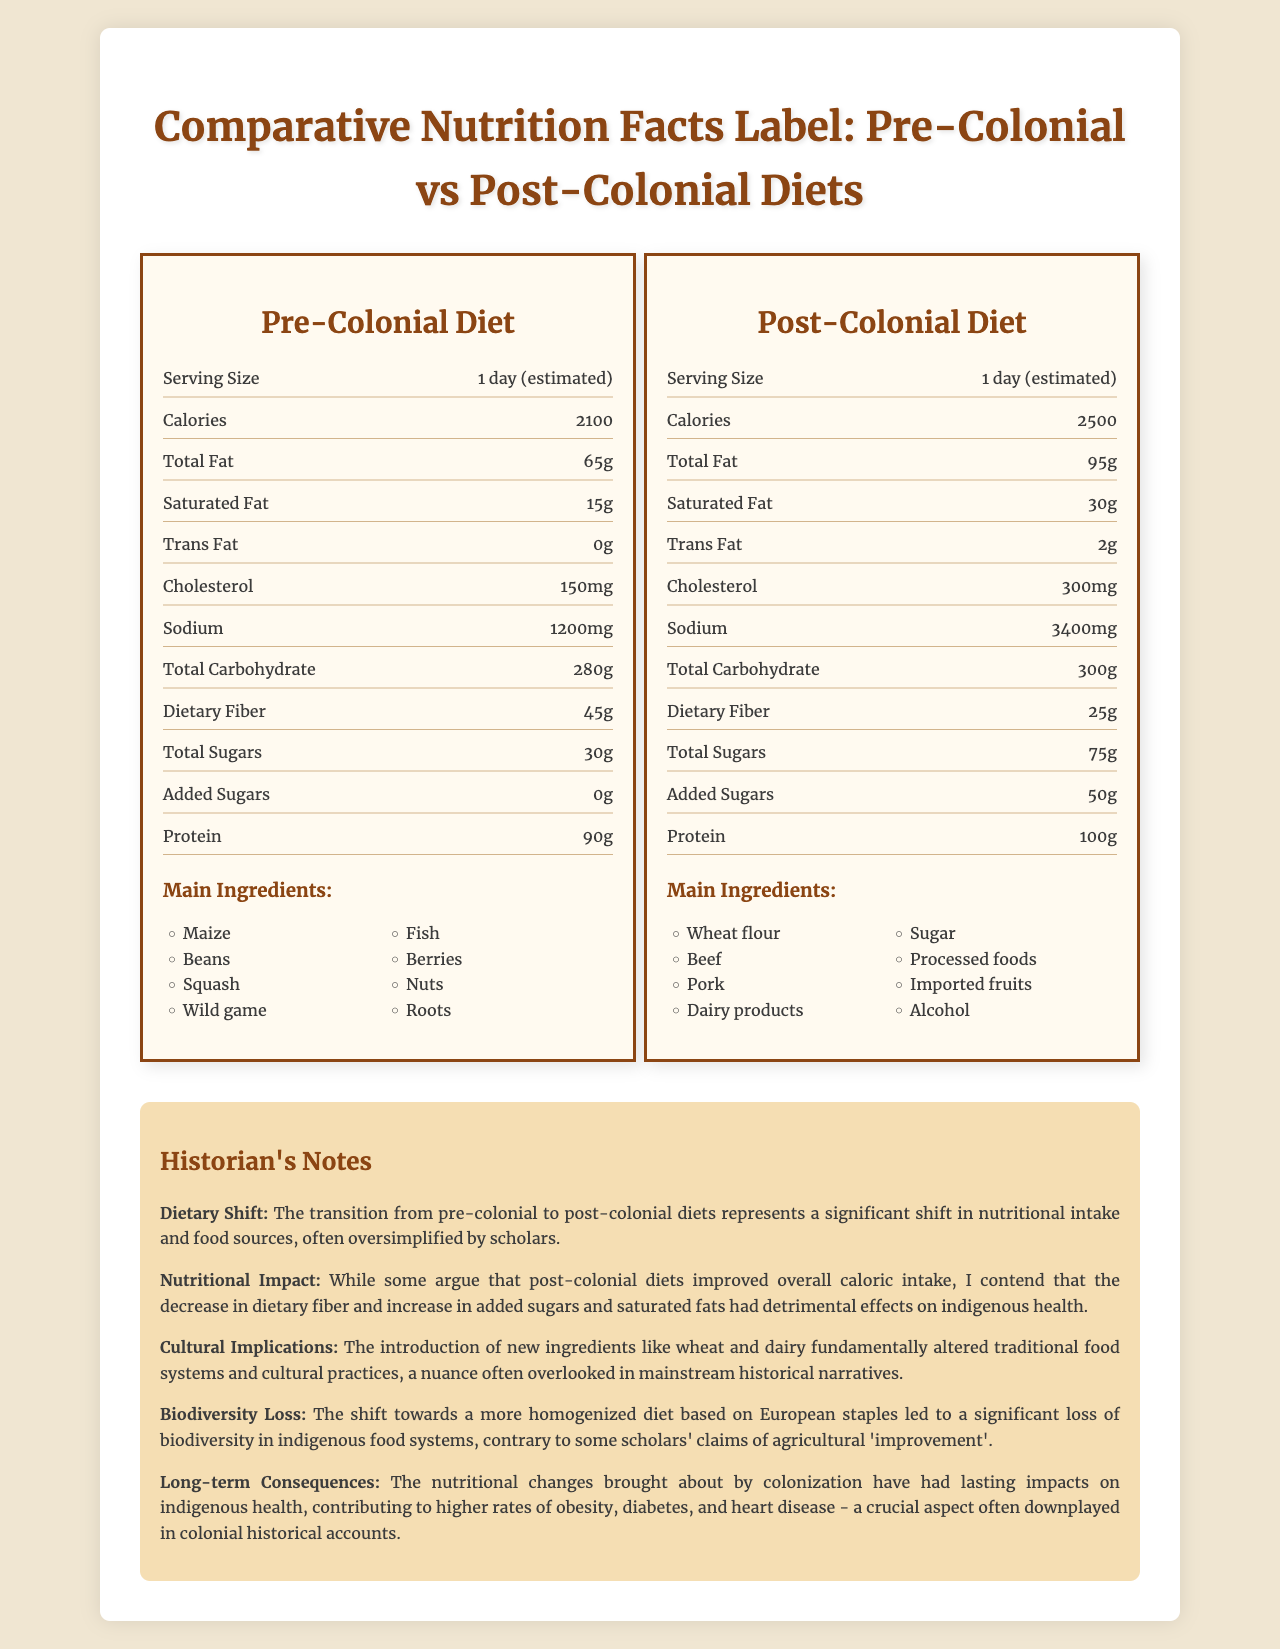how many calories are in the pre-colonial diet? The nutrition label for the pre-colonial diet lists the caloric intake as 2100.
Answer: 2100 what is the main source of carbohydrates in the pre-colonial diet? The main ingredients section lists maize, which is a primary source of carbohydrates in the pre-colonial diet.
Answer: Maize how much dietary fiber does the post-colonial diet provide? The nutrition label for the post-colonial diet indicates it provides 25 grams of dietary fiber.
Answer: 25 grams what is the amount of added sugars in the pre-colonial diet? The pre-colonial diet label shows that there are no added sugars.
Answer: 0 grams which diet has a higher total fat content? The post-colonial diet has 95 grams of total fat compared to 65 grams in the pre-colonial diet.
Answer: Post-colonial diet which diet is higher in sodium? A. Pre-colonial diet B. Post-colonial diet The nutrition label indicates that the post-colonial diet contains 3400 mg of sodium, whereas the pre-colonial diet contains 1200 mg.
Answer: B which vitamin is more abundant in the pre-colonial diet compared to the post-colonial diet? A. Vitamin A B. Vitamin C C. Vitamin D D. Vitamin E The pre-colonial diet has 85 mg of Vitamin C compared to 65 mg in the post-colonial diet.
Answer: B does the pre-colonial diet include any added sugars? The document clearly states that the pre-colonial diet has 0 grams of added sugars.
Answer: No how do the sources of protein differ between the pre-colonial and post-colonial diets? The main ingredients listed for the pre-colonial and post-colonial diets highlight these differences.
Answer: The pre-colonial diet includes wild game, fish, beans, and nuts, while the post-colonial diet includes beef, pork, and dairy products. which diet includes processed foods? The main ingredients for the post-colonial diet list processed foods, while the pre-colonial diet does not.
Answer: Post-colonial diet what is the historian's main critique of the dietary shift? The historian notes that while some argue caloric intake improved, they contend the negative health effects due to less dietary fiber and more added sugars and saturated fats are significant.
Answer: Decrease in dietary fiber and increase in added sugars and saturated fats detrimentally impacted indigenous health. summarize the main difference between the pre-colonial and post-colonial diets. The nutrition facts and main ingredients sections provide a contrast between the nutritional values and food sources from both time periods, alongside historian notes highlighting the negative impacts of these changes on indigenous health and cultural practices.
Answer: The pre-colonial diet is generally high in dietary fiber, low in added sugars, and includes diverse, natural foods such as maize, beans, and wild game. The post-colonial diet has higher calories, fat, added sugars, and sodium, with a shift towards processed foods and European staples like wheat and dairy. why did the total number of calories increase in the post-colonial diet compared to the pre-colonial diet? The document lists the calories for each diet but does not explain the reason for the increase.
Answer: Not enough information 